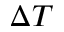Convert formula to latex. <formula><loc_0><loc_0><loc_500><loc_500>\Delta T</formula> 